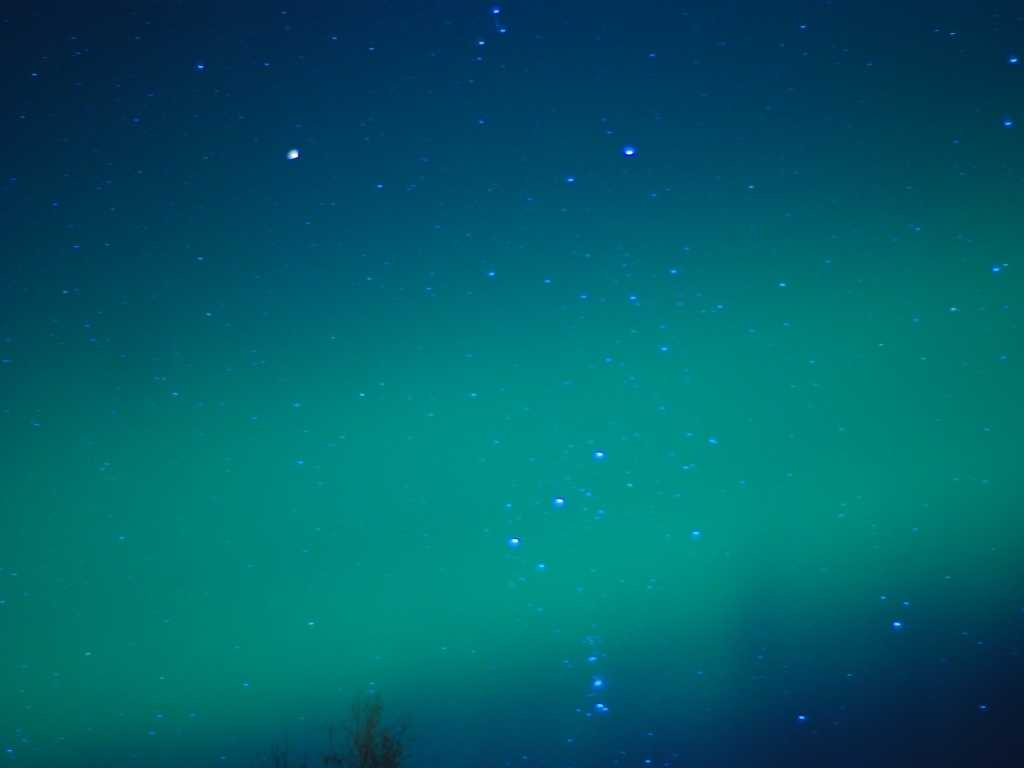What phenomenon could be depicted in this image? This image appears to capture the natural wonder of the Aurora Borealis, or Northern Lights, a spectacle of nature that paints the sky with flowing colors, often seen in high latitude regions. 